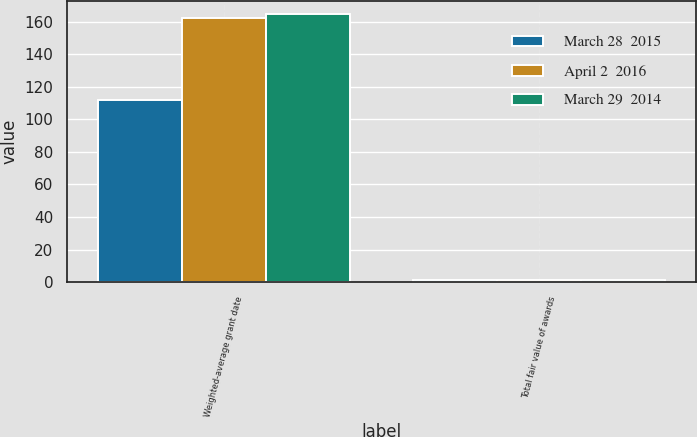<chart> <loc_0><loc_0><loc_500><loc_500><stacked_bar_chart><ecel><fcel>Weighted-average grant date<fcel>Total fair value of awards<nl><fcel>March 28  2015<fcel>111.94<fcel>1<nl><fcel>April 2  2016<fcel>162.36<fcel>1<nl><fcel>March 29  2014<fcel>164.76<fcel>1<nl></chart> 